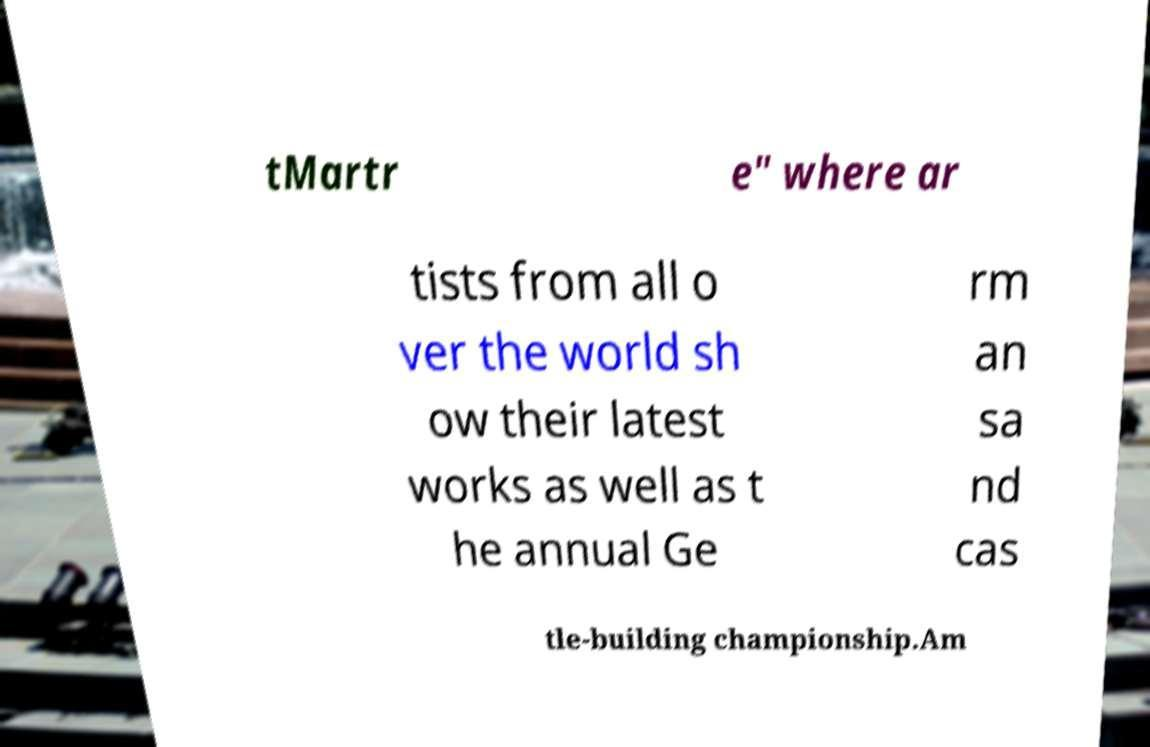Can you read and provide the text displayed in the image?This photo seems to have some interesting text. Can you extract and type it out for me? tMartr e" where ar tists from all o ver the world sh ow their latest works as well as t he annual Ge rm an sa nd cas tle-building championship.Am 